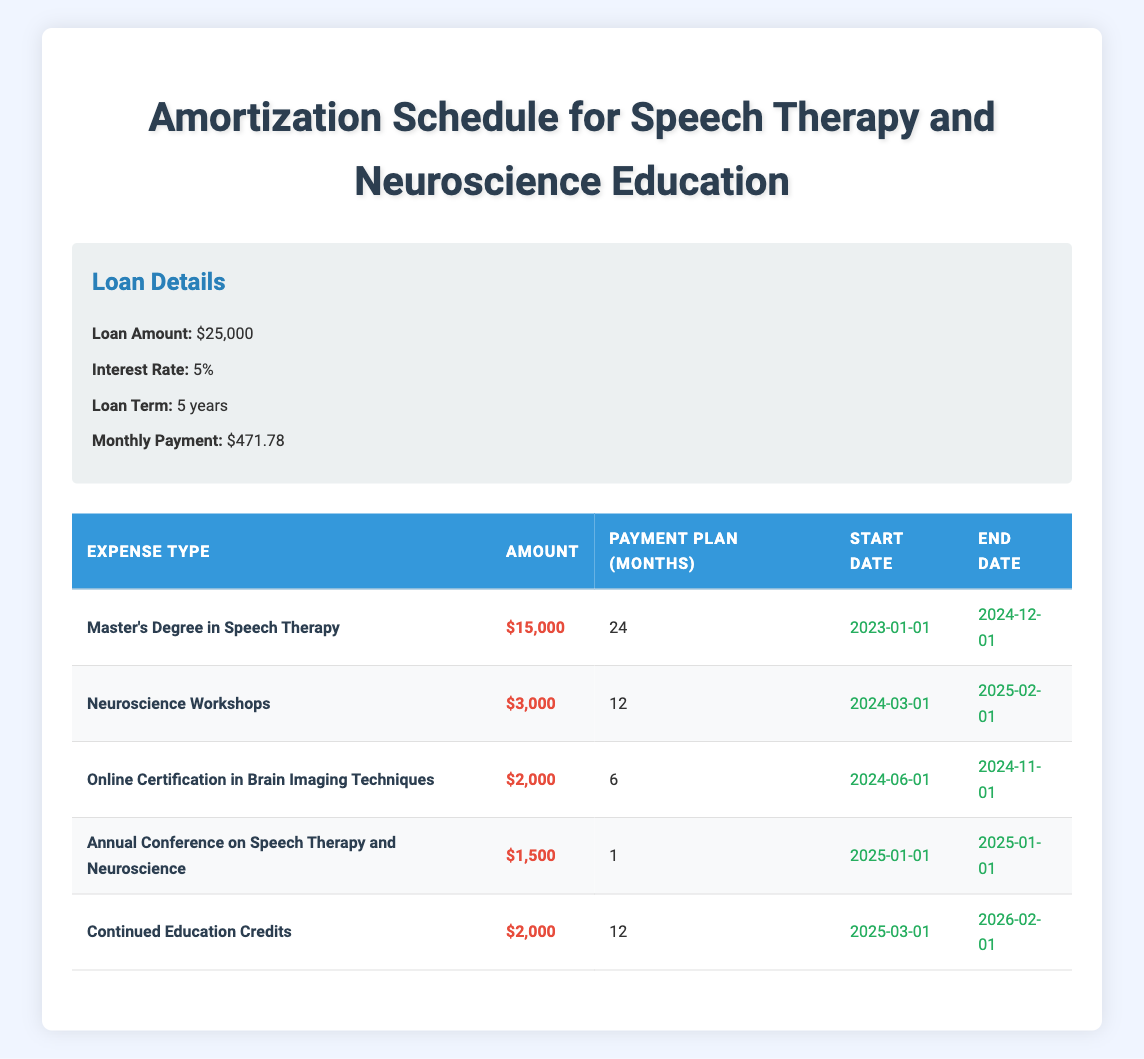What is the total amount of expenses for the Master's Degree in Speech Therapy? The table lists the expense for the Master's Degree in Speech Therapy as $15,000.
Answer: $15,000 How many months will payments for the Neuroscience Workshops last? The table shows the payment plan for the Neuroscience Workshops is 12 months.
Answer: 12 months What is the sum of the amounts for the Online Certification in Brain Imaging Techniques and the Annual Conference on Speech Therapy and Neuroscience? The Online Certification in Brain Imaging Techniques costs $2,000 and the Annual Conference costs $1,500. Summing these amounts: $2,000 + $1,500 = $3,500.
Answer: $3,500 Is the amount for Continued Education Credits greater than the amount for Neuroscience Workshops? The amount for Continued Education Credits is $2,000 and for Neuroscience Workshops is $3,000. Since $2,000 is not greater than $3,000, the statement is false.
Answer: No What is the duration of the payment plan for the Master's Degree in Speech Therapy compared to the Online Certification in Brain Imaging Techniques? The Master's Degree has a payment plan of 24 months while the Online Certification has a payment plan of 6 months. Since 24 months is greater than 6 months, the Master's payment plan is longer.
Answer: 24 months vs 6 months, longer What is the average payment plan duration for all educational expenses listed in the table? To find the average, we sum the payment plan months: 24 + 12 + 6 + 1 + 12 = 55 months. There are 5 expenses. The average is 55 / 5 = 11 months.
Answer: 11 months Does the sum of all educational expenses exceed $25,000? The total educational expenses are $15,000 (Master's) + $3,000 (Workshops) + $2,000 (Certification) + $1,500 (Conference) + $2,000 (Credits) = $23,500. Since $23,500 is less than $25,000, the statement is false.
Answer: No How many of the expenses listed have a payment duration of one month or less? The only expense with a payment duration of 1 month is the Annual Conference on Speech Therapy and Neuroscience. Therefore, there is one expense that meets this criterion.
Answer: 1 expense 